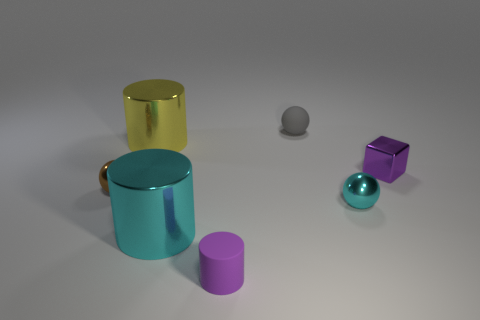Do the tiny ball to the right of the rubber sphere and the big metal cylinder in front of the cyan shiny sphere have the same color?
Your answer should be very brief. Yes. Is there another small thing that has the same shape as the tiny gray object?
Give a very brief answer. Yes. There is a object that is the same color as the small shiny cube; what is it made of?
Ensure brevity in your answer.  Rubber. What number of other objects are the same color as the shiny cube?
Your answer should be compact. 1. Does the shiny sphere that is to the left of the cyan shiny ball have the same size as the tiny purple block?
Offer a very short reply. Yes. What number of other objects are there of the same material as the tiny purple block?
Provide a succinct answer. 4. Are there the same number of purple matte cylinders behind the brown thing and purple metal cubes to the right of the tiny purple metallic object?
Ensure brevity in your answer.  Yes. What is the color of the ball right of the small ball behind the small metallic thing to the left of the tiny gray ball?
Give a very brief answer. Cyan. What is the shape of the thing to the right of the small cyan thing?
Keep it short and to the point. Cube. What shape is the purple thing that is the same material as the gray sphere?
Keep it short and to the point. Cylinder. 